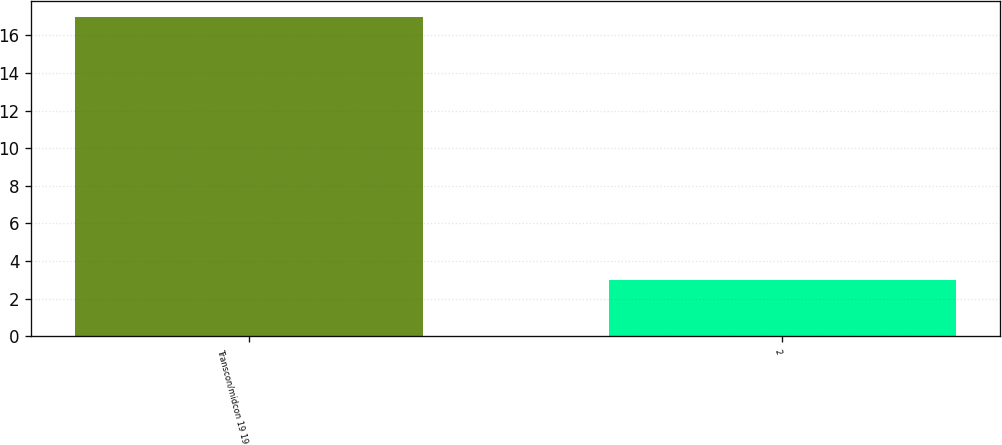Convert chart. <chart><loc_0><loc_0><loc_500><loc_500><bar_chart><fcel>Transcon/midcon 19 19<fcel>2<nl><fcel>17<fcel>3<nl></chart> 